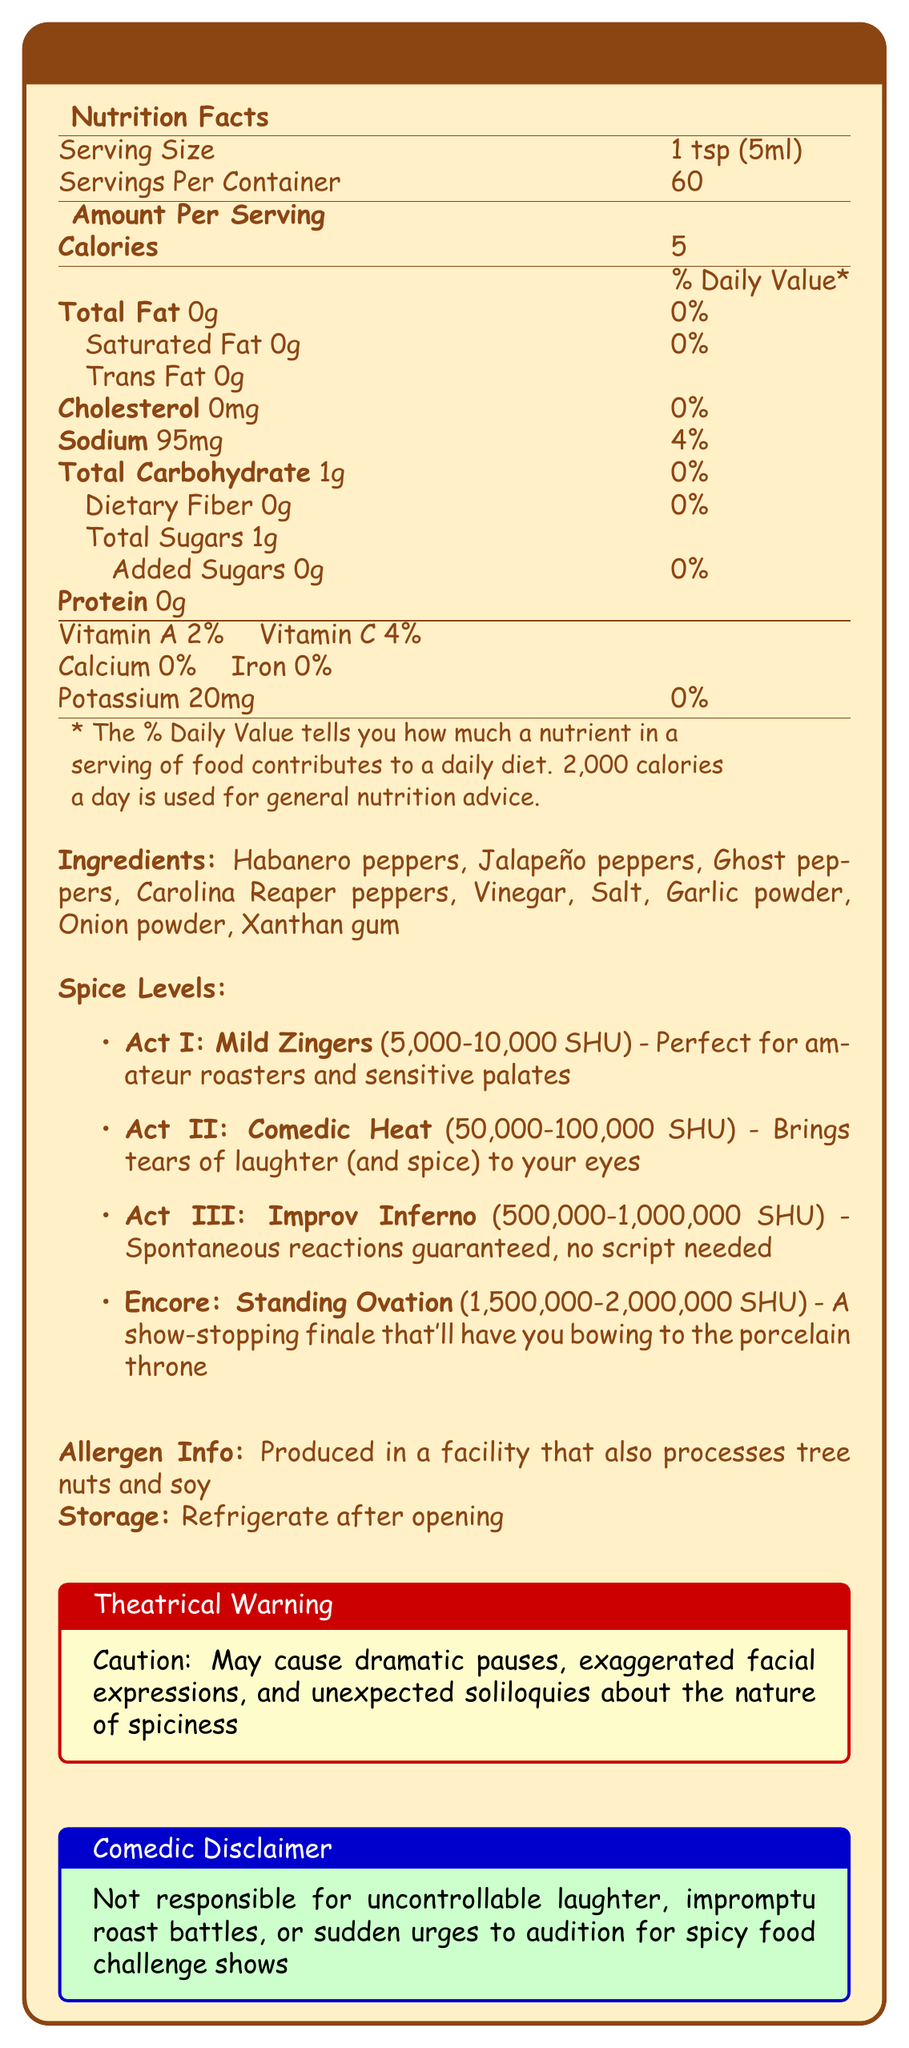what is the serving size? The serving size is directly stated in the document.
Answer: 1 tsp (5ml) how many calories are in one serving? The number of calories per serving is listed in the nutrition facts.
Answer: 5 calories how much sodium does one serving contain? The amount of sodium per serving is mentioned in the nutrition facts section.
Answer: 95mg what percentage of daily Vitamin C does one serving provide? The daily Vitamin C percentage is specified under the vitamin content.
Answer: 4% what are the four spice levels of the hot sauce? The four spice levels are listed under "Spice Levels" with their respective names.
Answer: Act I: Mild Zingers, Act II: Comedic Heat, Act III: Improv Inferno, Encore: Standing Ovation which ingredient is listed first in the ingredients list? The first ingredient in the list is Habanero peppers.
Answer: Habanero peppers what is the Scoville unit range for Act II: Comedic Heat? The Scoville unit range for Comedic Heat is displayed under spice levels.
Answer: 50,000-100,000 SHU what proteins are found in one serving of this sauce? The protein content in one serving is stated as 0g in the nutrition facts.
Answer: 0g which vitamin has a 2% daily value in this hot sauce? Under the vitamin content, Vitamin A has a 2% daily value.
Answer: Vitamin A where should the hot sauce be stored after opening? The document advises refrigerating the sauce after opening under the storage section.
Answer: Refrigerate which allergens might the hot sauce contain? The allergen information indicates that the sauce is produced in a facility that also processes tree nuts and soy.
Answer: Tree nuts and soy which item does NOT belong in the ingredient list: Habanero peppers, Xanthan gum, Sugar, Garlic powder? The ingredient list does not include sugar; it includes Habanero peppers, Xanthan gum, and Garlic powder.
Answer: Sugar what is the significance of 'Theatrical Warning'? The Theatrical Warning cautions users about potential dramatic and humorous effects of consuming the sauce, as detailed in the document.
Answer: Caution about dramatic pauses, exaggerated facial expressions, and unexpected soliloquies according to the comedic disclaimer, what are users NOT responsible for? A. Uncontrollable laughter, B. Impromptu roast battles, C. Sudden urges to audition for spicy food challenge shows, D. Heartburn The comedic disclaimer mentions A, B, and C are not the user's responsibility, but not D.
Answer: D how much potassium is in one serving? The nutrition facts specify that one serving contains 20mg of potassium.
Answer: 20mg does the document suggest that the hot sauce contain added sugars? The nutrition facts state there are 0g of added sugars in the sauce.
Answer: No can we determine the exact number of Calories in the whole bottle? The document lists Calories per serving but not the total number, so math must be done to determine the bottle’s total Calories.
Answer: No summarize the main idea of the document The summary covers all aspects of the document, focusing on its nutritional, ingredient, and special comedy and spice-themed information.
Answer: The document is a detailed nutrition facts label for Family Roast Master Hot Sauce, highlighting its serving size, nutritional content, ingredients, spice levels, allergen information, storage instructions, and humorous disclaimers 